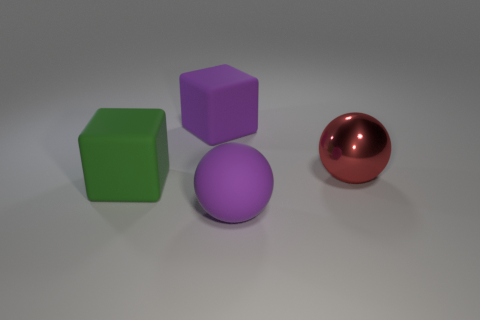Add 4 tiny red rubber things. How many objects exist? 8 Add 4 large green matte blocks. How many large green matte blocks are left? 5 Add 2 big red shiny objects. How many big red shiny objects exist? 3 Subtract 0 brown spheres. How many objects are left? 4 Subtract all big red rubber balls. Subtract all purple objects. How many objects are left? 2 